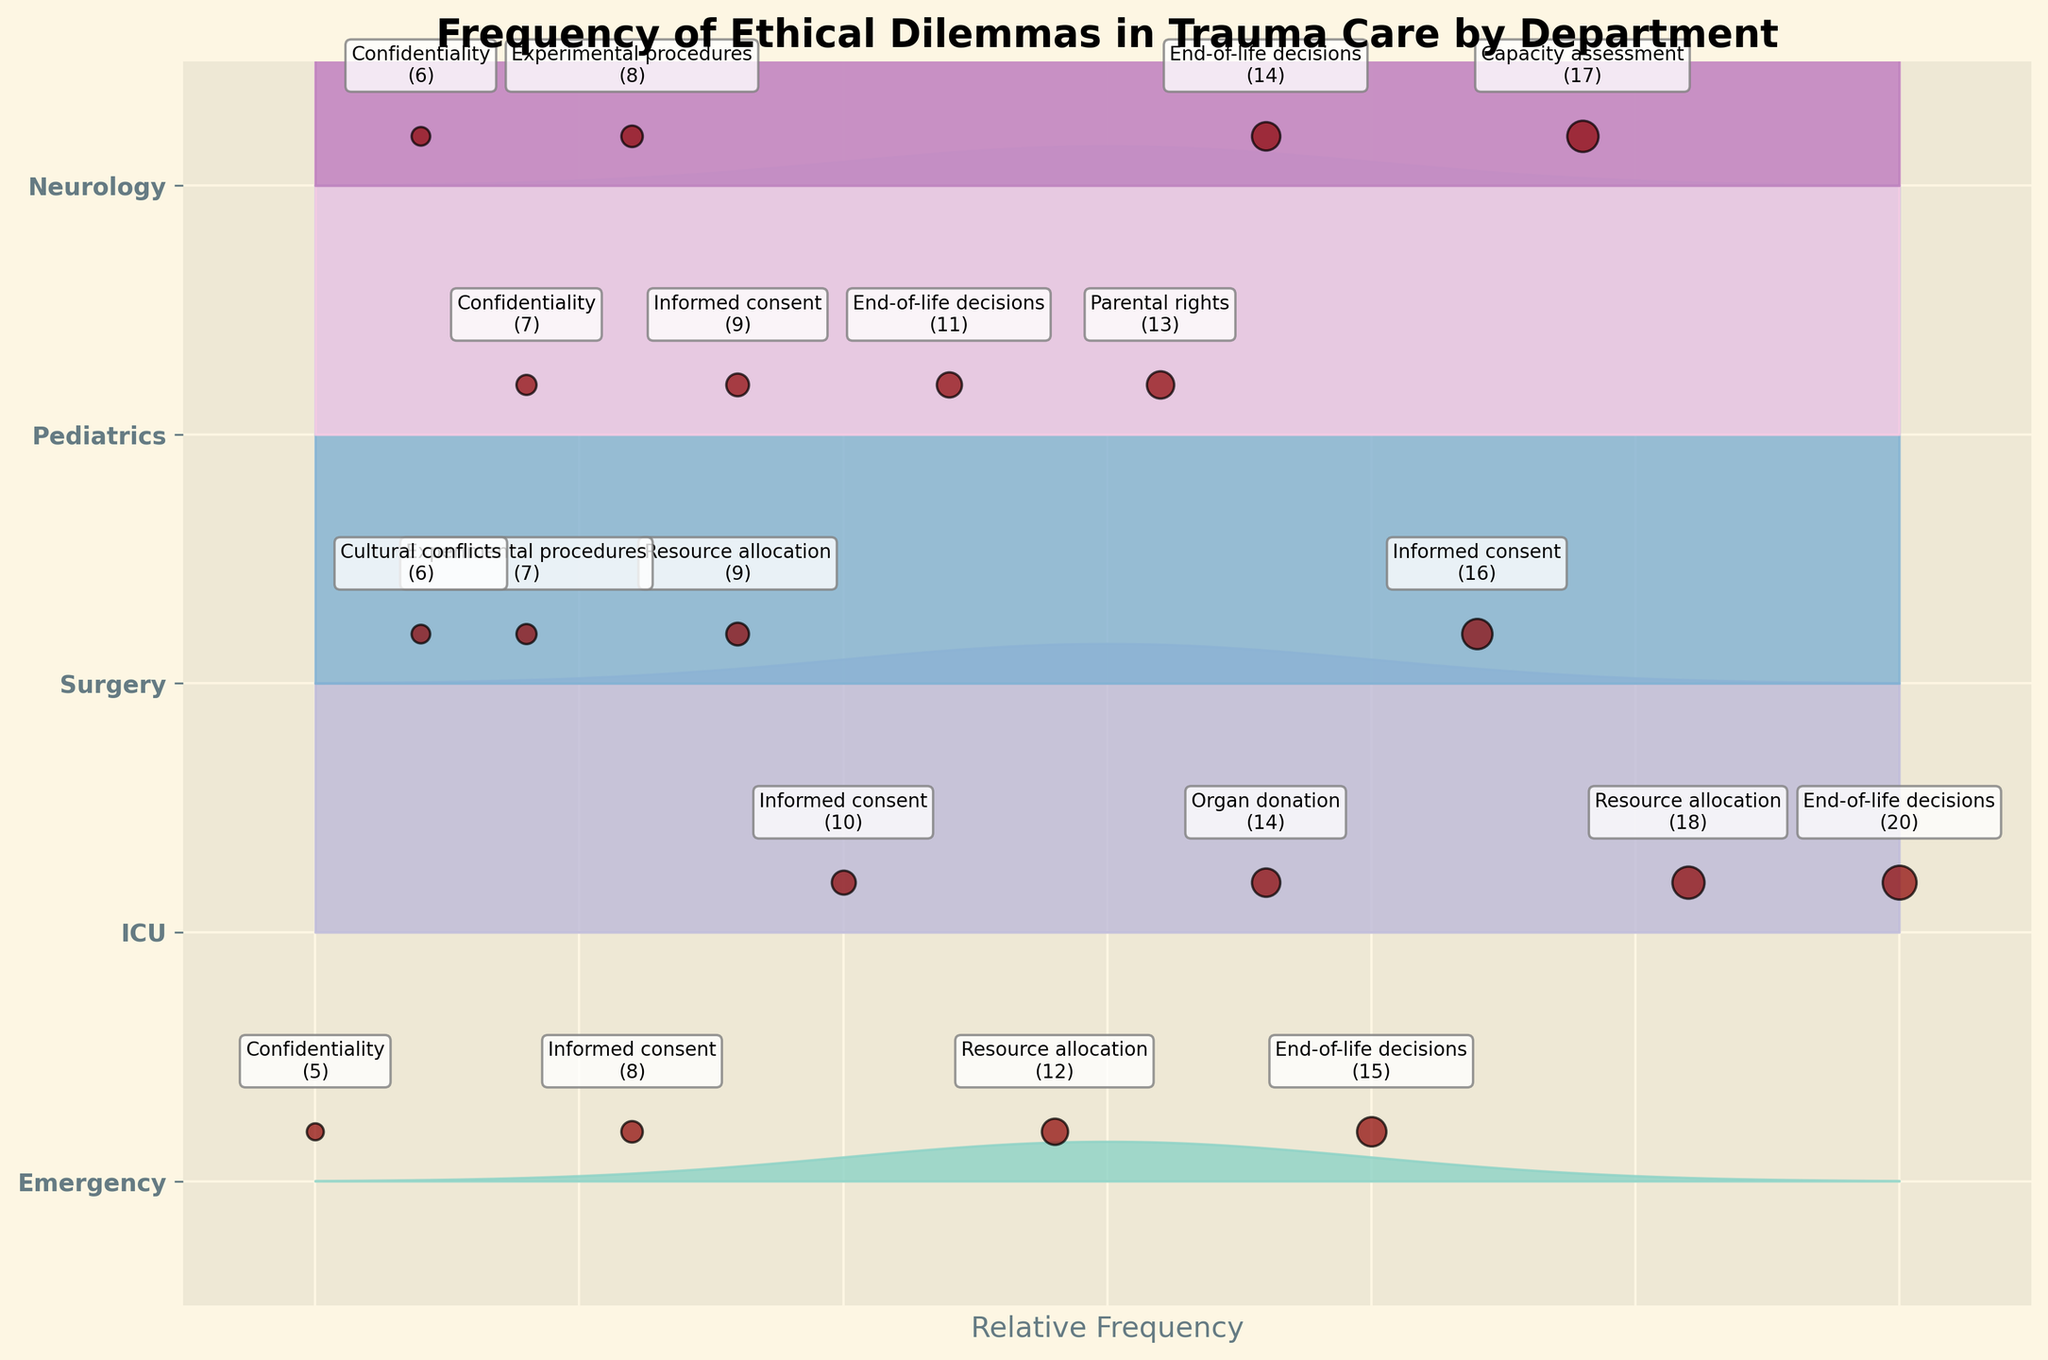What is the title of the plot? The title is usually located at the top of the figure. In this case, it reads "Frequency of Ethical Dilemmas in Trauma Care by Department."
Answer: Frequency of Ethical Dilemmas in Trauma Care by Department How many departments are displayed in the plot? Count the unique y-tick labels, which represent the different departments. These are "Emergency," "ICU," "Surgery," "Pediatrics," and "Neurology."
Answer: 5 Which department has the highest frequency for the dilemma "End-of-life decisions"? Identify the scatter points for "End-of-life decisions" and check their frequency labels. The ICU department has a frequency of 20, which is higher than other departments.
Answer: ICU What is the relative frequency range used in the plot? Look at the x-axis range, which varies from -3.5 to 3.5, indicating the relative frequency range.
Answer: -3.5 to 3.5 Compare the frequency of "Informed consent" dilemmas in the Emergency and Surgery departments. Which has a higher frequency? Find the scatter points for "Informed consent" in both departments and read the frequency labels. Emergency has a frequency of 8, while Surgery has 16. Surgery has a higher frequency.
Answer: Surgery Which department has the most varied types of ethical dilemmas? Count the unique dilemmas for each department. Emergency has 4, ICU has 4, Surgery has 4, Pediatrics has 4, and Neurology has 4. Each department has an equal variety of dilemmas.
Answer: All equal What dilemma in the Neurology department has the second highest frequency? Identify each dilemma in the Neurology department and their frequencies. "End-of-life decisions" has 14, "Capacity assessment" has 17, making "End-of-life decisions" the second highest.
Answer: End-of-life decisions How does the frequency of "Experimental procedures" dilemmas in Surgery compare to the same dilemma in Neurology? Identify the scatter points for "Experimental procedures" in both departments. Surgery has a frequency of 7, while Neurology has 8. Neurology has a higher frequency.
Answer: Neurology Which department has the least number of consultations for "Confidentiality" dilemmas? Identify the scatter points for "Confidentiality" and their frequencies in the relevant departments. Emergency has a frequency of 5, which is the lowest.
Answer: Emergency What is the total number of consultation requests for "Resource allocation" dilemmas across all departments? Sum the frequencies of "Resource allocation" across all departments: Emergency (12) + ICU (18) + Surgery (9) = 39.
Answer: 39 